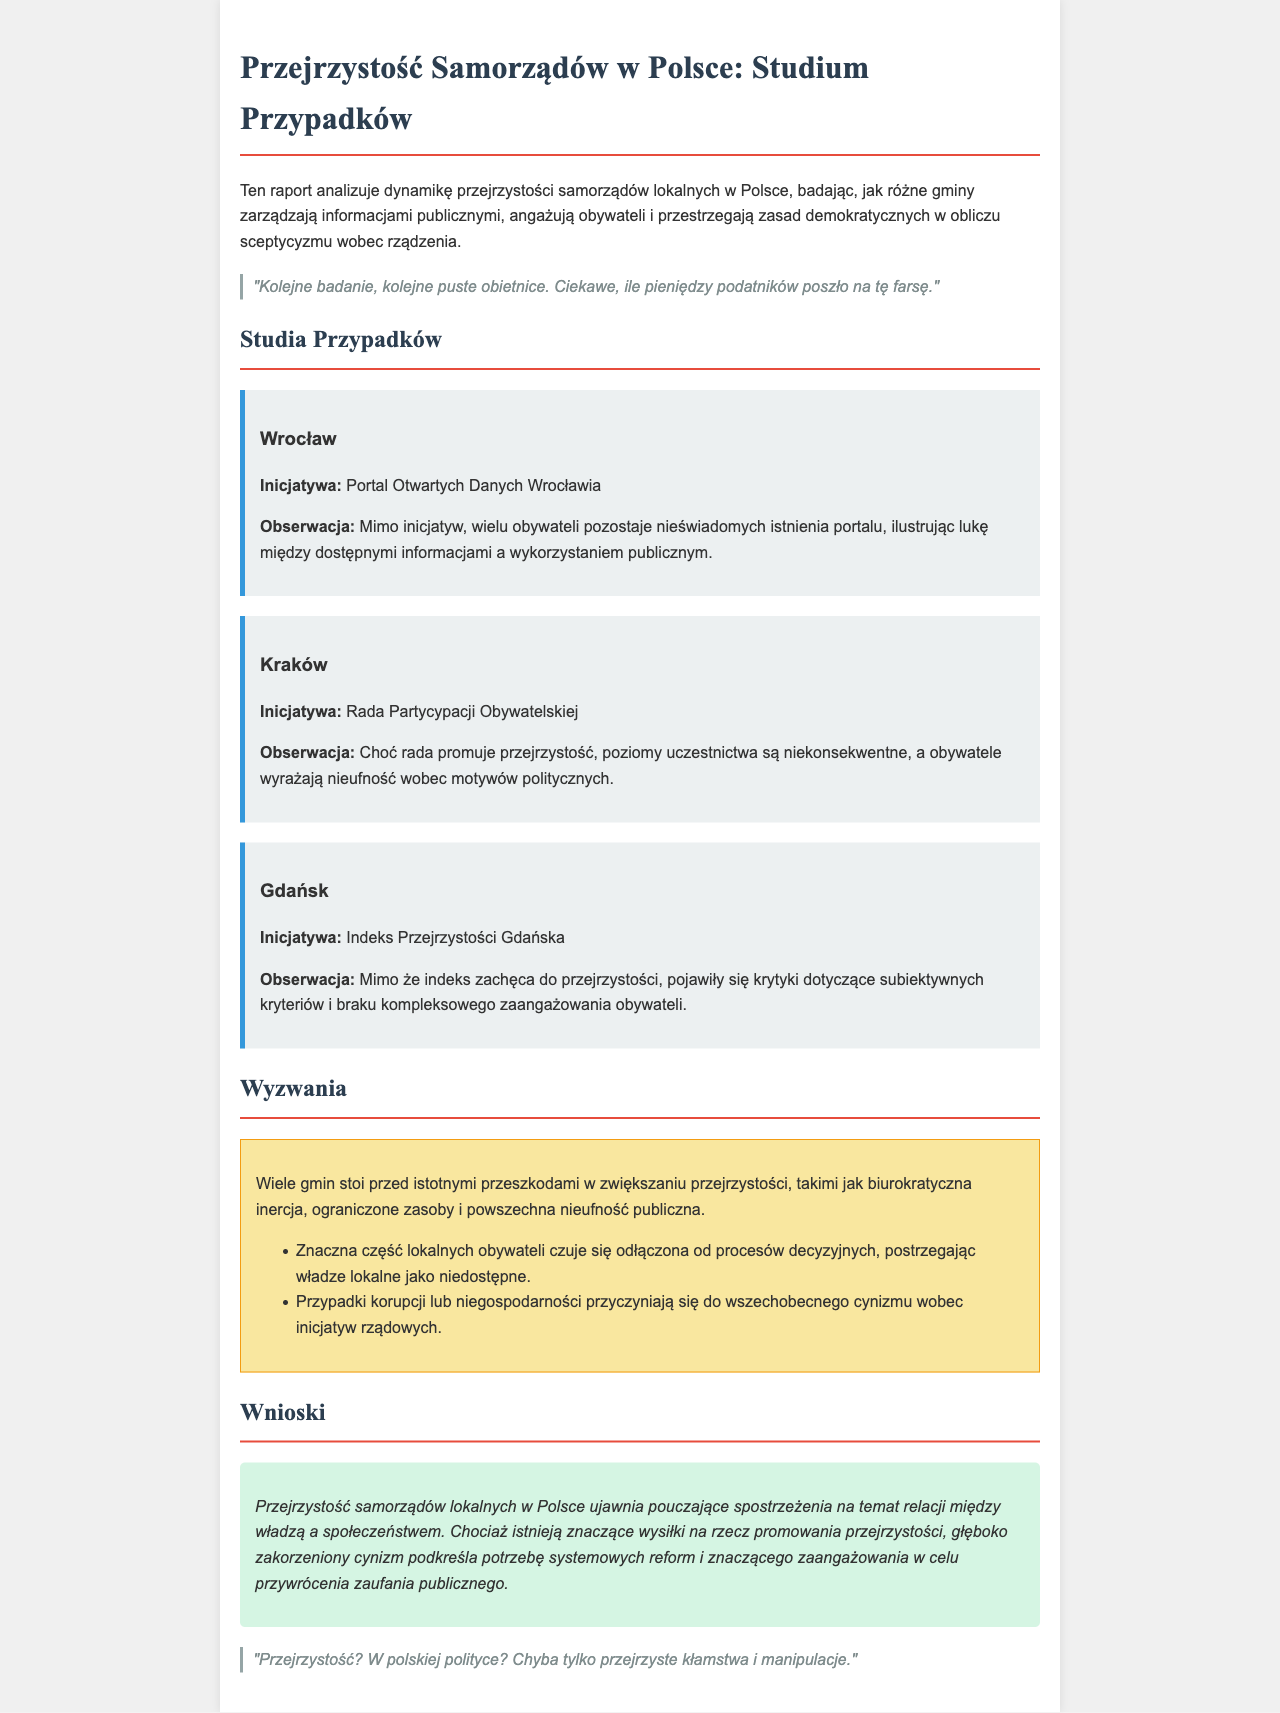What is the title of the report? The title of the report is presented prominently at the top of the document, indicating the focus on local government transparency in Poland.
Answer: Przejrzystość Samorządów w Polsce: Studium Przypadków Which municipality is associated with the "Portal Otwartych Danych"? The report explicitly mentions Wrocław in connection to the "Portal Otwartych Danych".
Answer: Wrocław What is a challenge mentioned regarding local government transparency? The document lists several obstacles, highlighting the bureaucratic inertia as a significant challenge faced by municipalities.
Answer: Biurokratyczna inercja What initiative promotes citizen participation in Kraków? The report identifies the "Rada Partycypacji Obywatelskiej" as the initiative that aims to enhance citizen engagement in Kraków.
Answer: Rada Partycypacji Obywatelskiej What is the overall conclusion about local government transparency in Poland? The conclusion emphasizes the need for systemic reforms and significant engagement to regain public trust amid deep-seated cynicism.
Answer: Systemowych reform What criticism is directed at the Gdańsk's Indeks Przejrzystości? Criticisms brought up in the document point to the subjective criteria used and the lack of comprehensive citizen involvement.
Answer: Subiektywnych kryteriów What do many citizens feel regarding local decision-making processes? The report mentions that a significant portion of citizens feels disconnected from the decision-making processes.
Answer: Odłączona How does the document describe the public sentiment towards government initiatives? It suggests that public sentiment is largely characterized by skepticism, particularly due to past instances of corruption.
Answer: Nieufność 